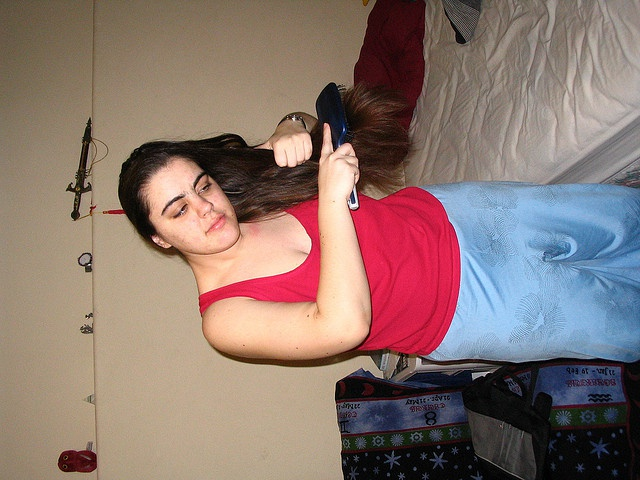Describe the objects in this image and their specific colors. I can see people in darkgreen, black, brown, tan, and lightblue tones, bed in darkgreen, darkgray, gray, and black tones, and chair in darkgreen, black, navy, gray, and darkblue tones in this image. 